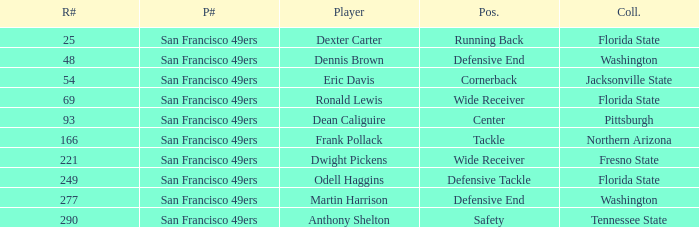What is the College with a Player that is dean caliguire? Pittsburgh. 